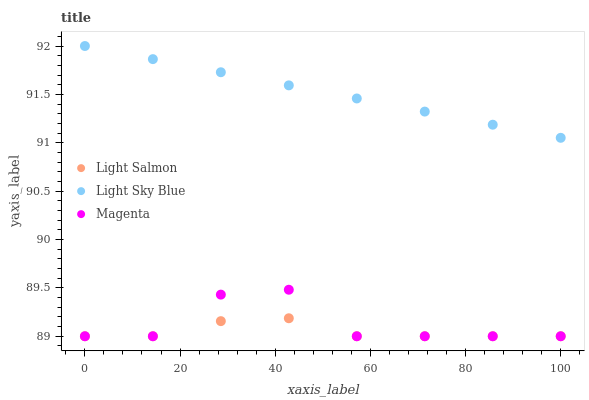Does Light Salmon have the minimum area under the curve?
Answer yes or no. Yes. Does Light Sky Blue have the maximum area under the curve?
Answer yes or no. Yes. Does Magenta have the minimum area under the curve?
Answer yes or no. No. Does Magenta have the maximum area under the curve?
Answer yes or no. No. Is Light Sky Blue the smoothest?
Answer yes or no. Yes. Is Magenta the roughest?
Answer yes or no. Yes. Is Magenta the smoothest?
Answer yes or no. No. Is Light Sky Blue the roughest?
Answer yes or no. No. Does Light Salmon have the lowest value?
Answer yes or no. Yes. Does Light Sky Blue have the lowest value?
Answer yes or no. No. Does Light Sky Blue have the highest value?
Answer yes or no. Yes. Does Magenta have the highest value?
Answer yes or no. No. Is Magenta less than Light Sky Blue?
Answer yes or no. Yes. Is Light Sky Blue greater than Light Salmon?
Answer yes or no. Yes. Does Magenta intersect Light Salmon?
Answer yes or no. Yes. Is Magenta less than Light Salmon?
Answer yes or no. No. Is Magenta greater than Light Salmon?
Answer yes or no. No. Does Magenta intersect Light Sky Blue?
Answer yes or no. No. 